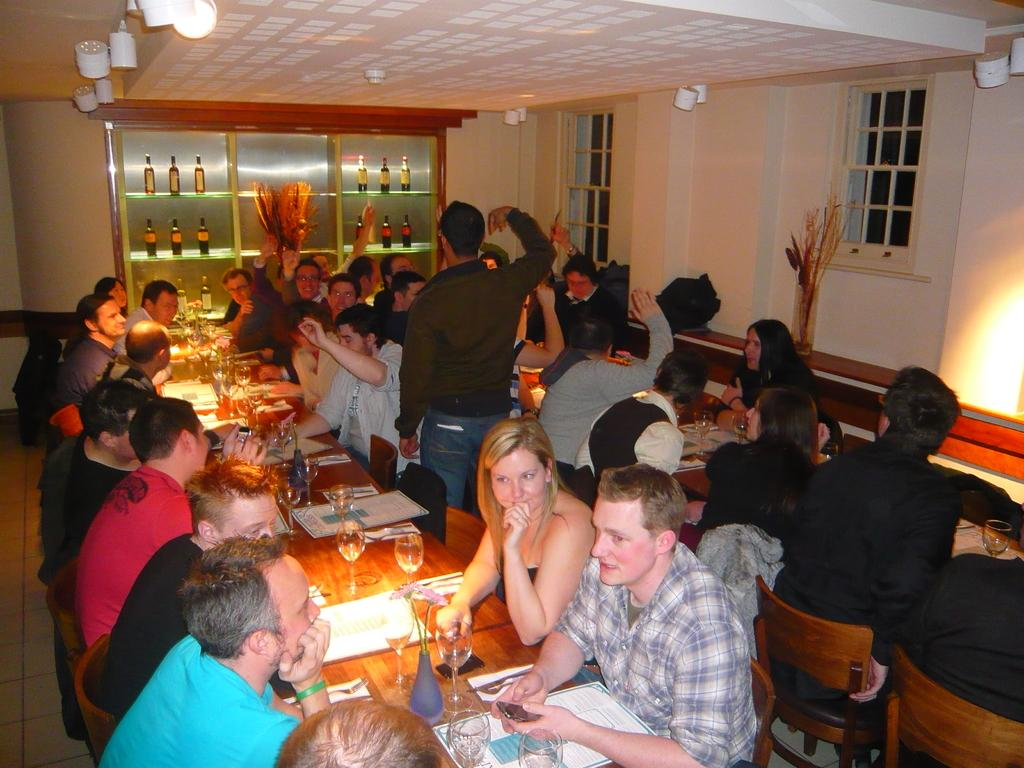What are the people in the image doing? The people in the image are sitting on chairs. What objects can be seen on the table in the image? There are glasses on a table in the image. What else can be seen in the background of the image? There are bottles visible in the background of the image. What type of pencil is being used by the person sitting on the chair in the image? There is no pencil visible in the image; the people are sitting on chairs and there are glasses on a table, but no pencil is present. 